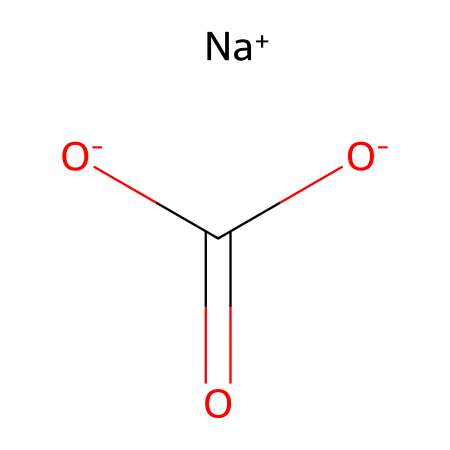How many sodium ions are present in this structure? The SMILES representation shows a sodium ion represented as [Na+]. There is one occurrence of [Na+] in the structure.
Answer: one What functional groups are present in sodium bicarbonate? The SMILES indicates two carboxylate groups, as shown by the presence of C(=O)[O-]. These indicate the presence of acidic functional groups in the molecule.
Answer: carboxylate What is the total number of carbon atoms in sodium bicarbonate? Looking at the SMILES, there is one carbon atom indicated by C in the structure, and no other carbon atoms are visible.
Answer: one What is the charge of the bicarbonate ion in this structure? The bicarbonate ion is depicted as -[O-]C(=O)[O-], which has a total of one negative charge since there are two oxygen atoms with negative charges.
Answer: one negative charge Is sodium bicarbonate an acid or a base? Given the presence of the carboxylate structure in this compound and its ability to accept protons, sodium bicarbonate can be classified as a weak base.
Answer: weak base What type of bonding is present between the sodium ion and bicarbonate ion? The sodium ion is ionically bonded to the bicarbonate ion, indicated by the interaction of the [Na+] and the negatively charged [O-] from the bicarbonate structure.
Answer: ionic bonding What is the total number of oxygen atoms in sodium bicarbonate? In the structure, there are three oxygen atoms. Two are from the carboxylate and the third is associated with the negative charge seen in the bicarbonate.
Answer: three 